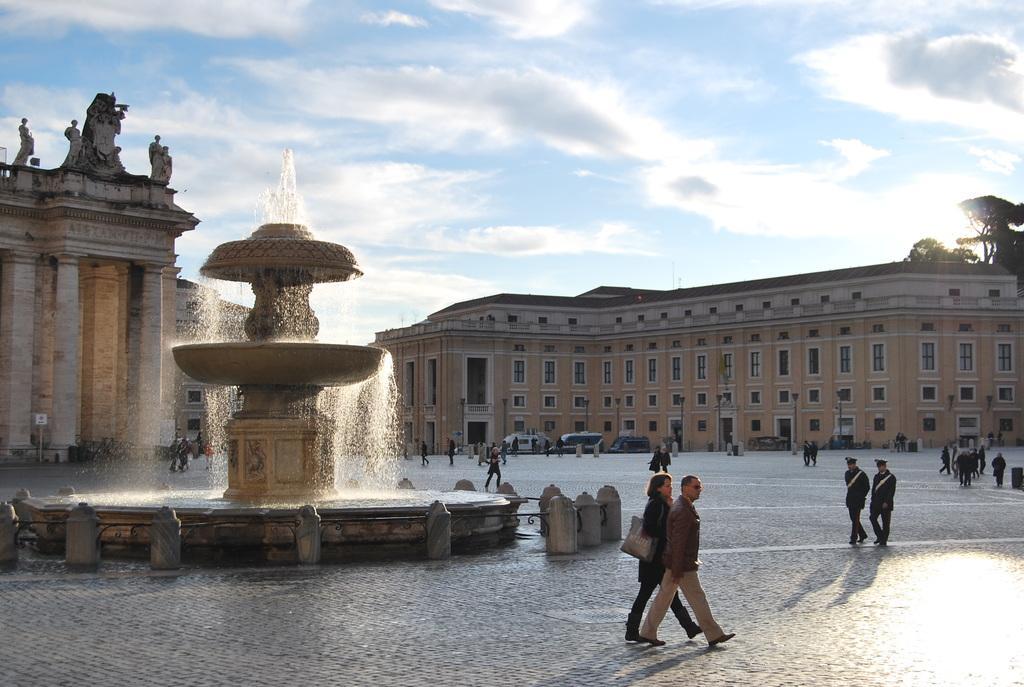Could you give a brief overview of what you see in this image? In this image I can see few buildings, sculptures, water fountain, few trees, clouds, the sky, few vehicles over there and I can also see number of people are standing. 